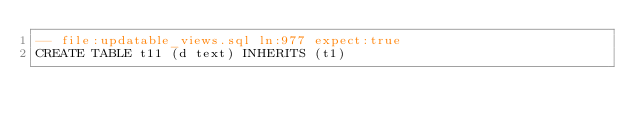Convert code to text. <code><loc_0><loc_0><loc_500><loc_500><_SQL_>-- file:updatable_views.sql ln:977 expect:true
CREATE TABLE t11 (d text) INHERITS (t1)
</code> 